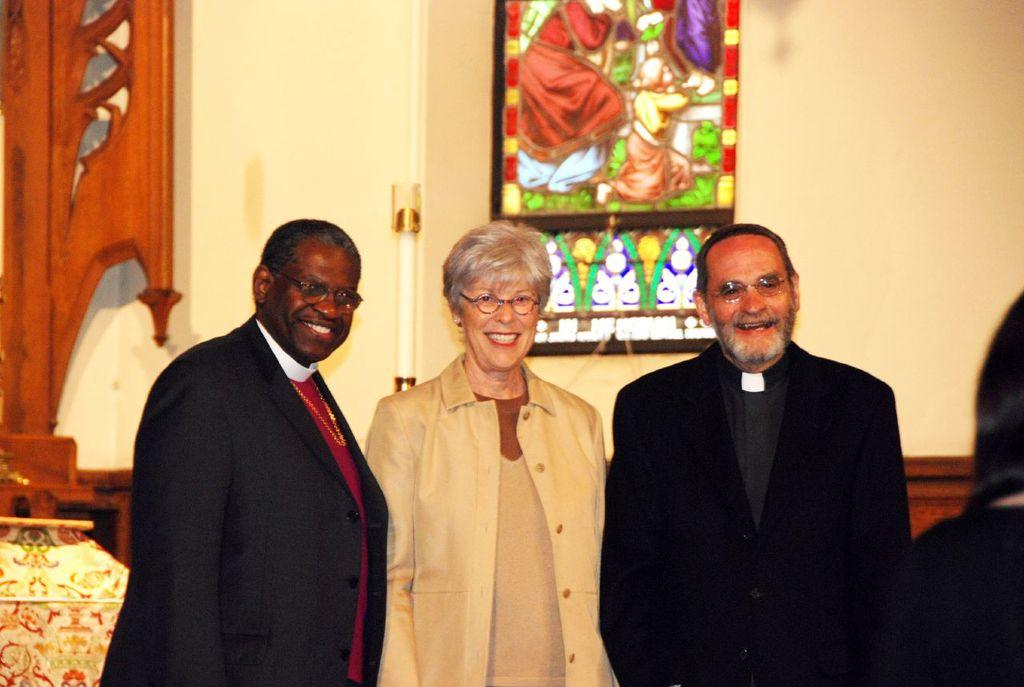What is happening in the image? There are people standing in the image. Can you describe the clothing of the people? The people are wearing different color dresses. What else can be seen in the image besides the people? There is a frame in the image. Where is the frame located? The frame is attached to a cream-colored wall. What type of corn is being harvested by the woman in the image? There is no woman or corn present in the image; it only features people wearing different color dresses, a frame, and a cream-colored wall. 